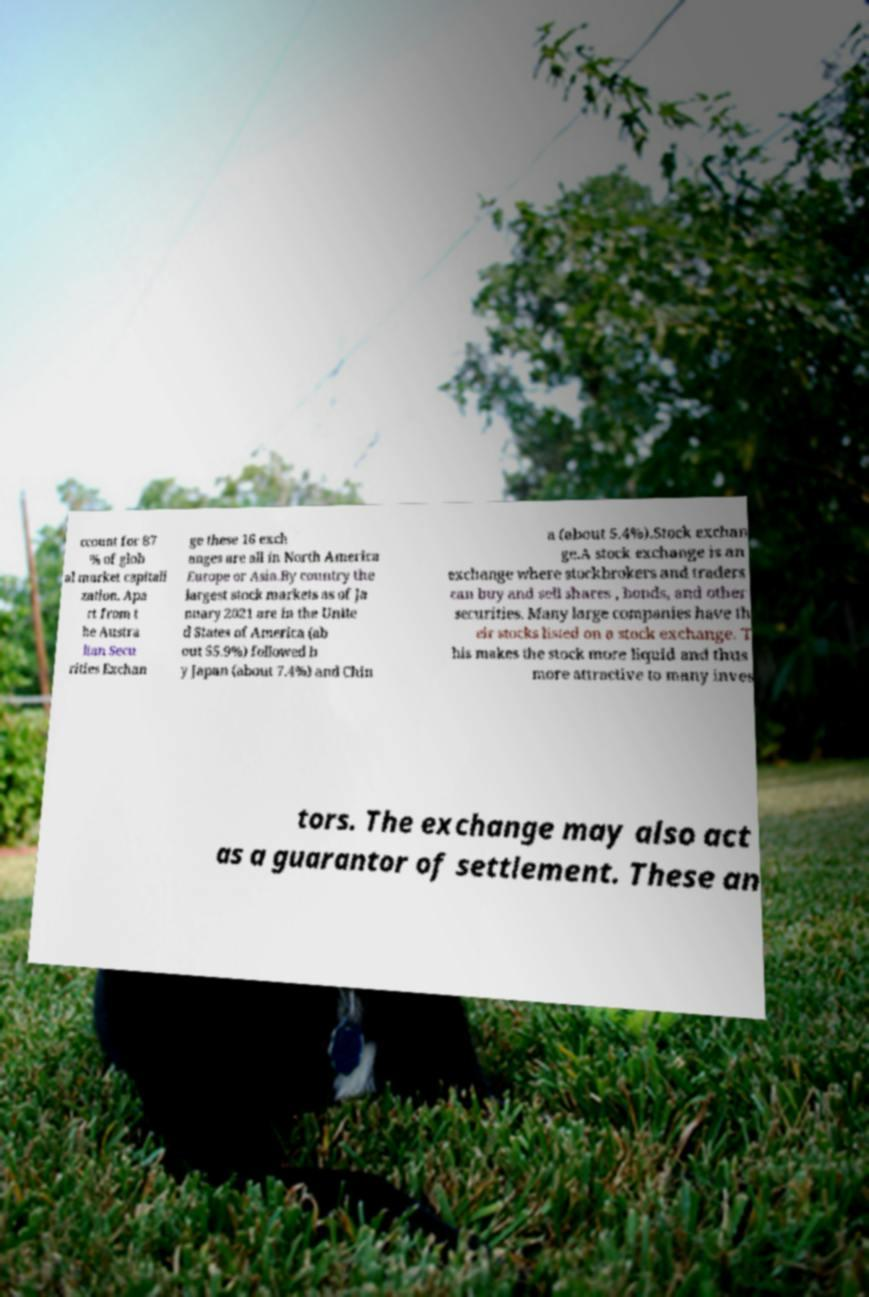For documentation purposes, I need the text within this image transcribed. Could you provide that? ccount for 87 % of glob al market capitali zation. Apa rt from t he Austra lian Secu rities Exchan ge these 16 exch anges are all in North America Europe or Asia.By country the largest stock markets as of Ja nuary 2021 are in the Unite d States of America (ab out 55.9%) followed b y Japan (about 7.4%) and Chin a (about 5.4%).Stock exchan ge.A stock exchange is an exchange where stockbrokers and traders can buy and sell shares , bonds, and other securities. Many large companies have th eir stocks listed on a stock exchange. T his makes the stock more liquid and thus more attractive to many inves tors. The exchange may also act as a guarantor of settlement. These an 